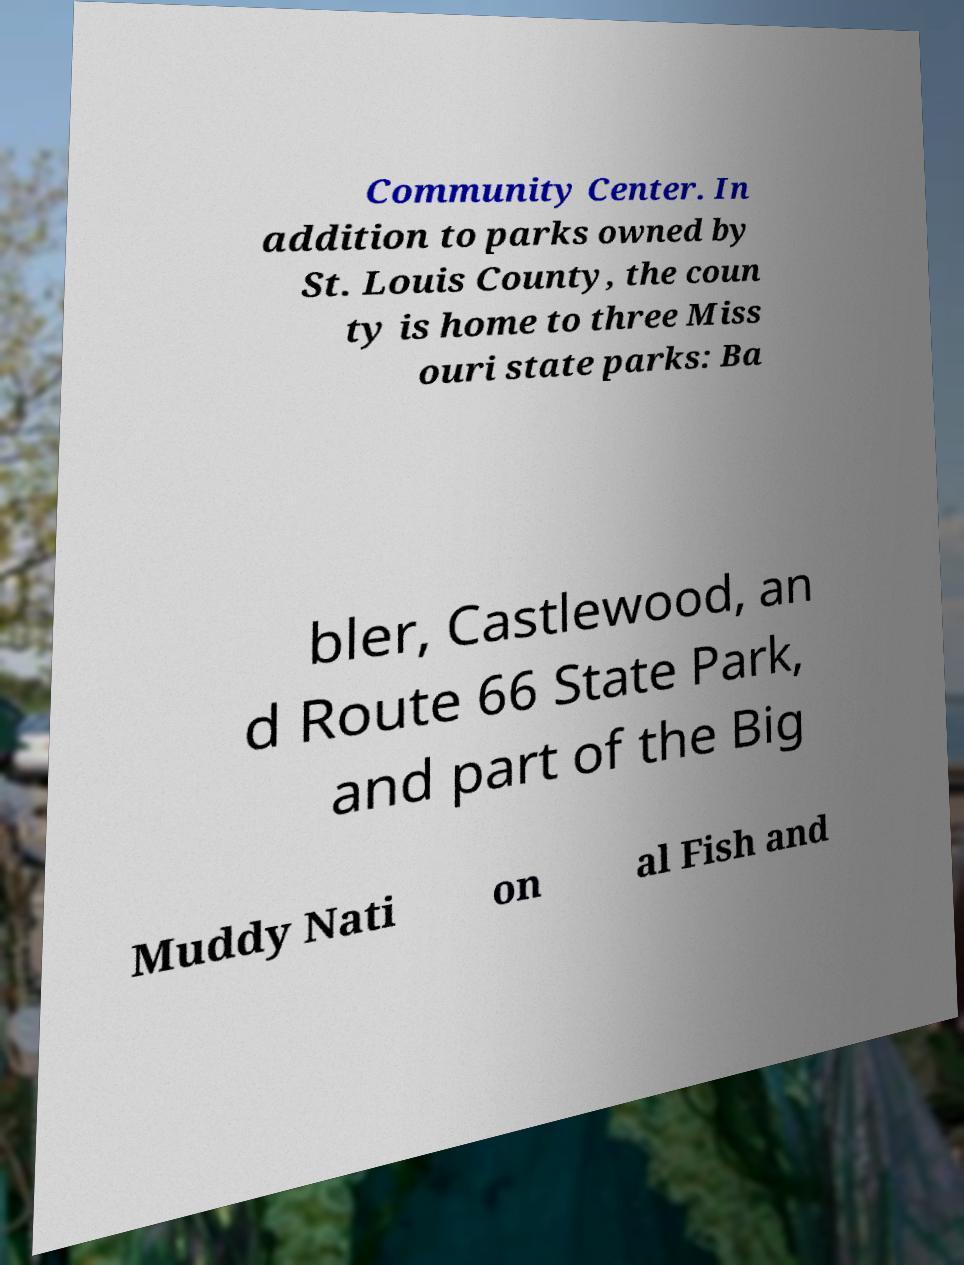Please identify and transcribe the text found in this image. Community Center. In addition to parks owned by St. Louis County, the coun ty is home to three Miss ouri state parks: Ba bler, Castlewood, an d Route 66 State Park, and part of the Big Muddy Nati on al Fish and 